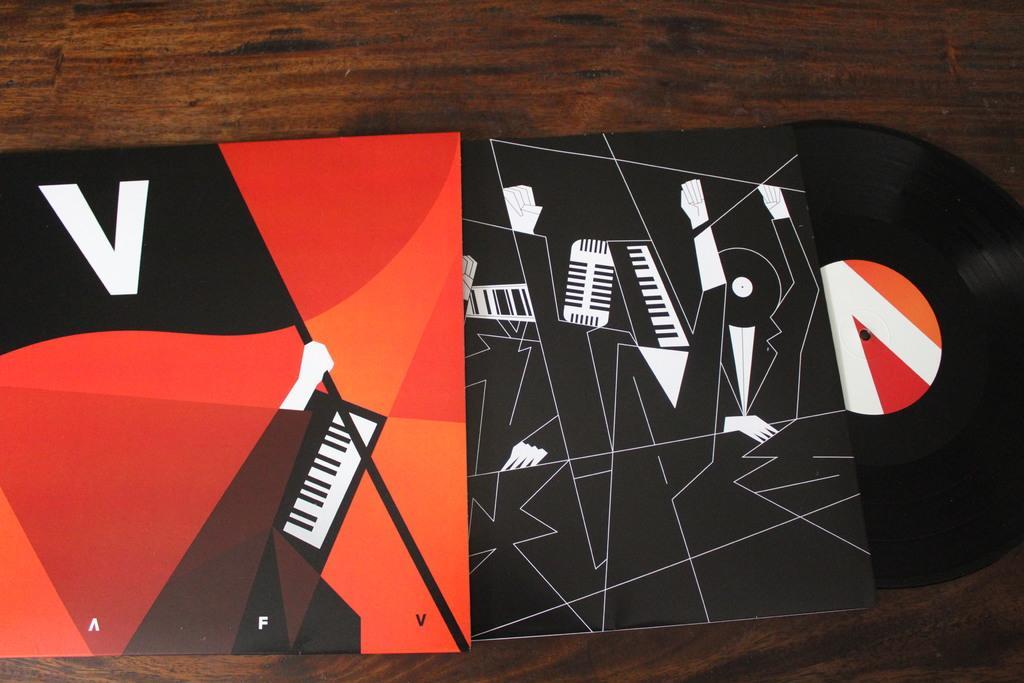In one or two sentences, can you explain what this image depicts? In this image I can see an object in red, orange, black and white color. It is on the brown surface. 